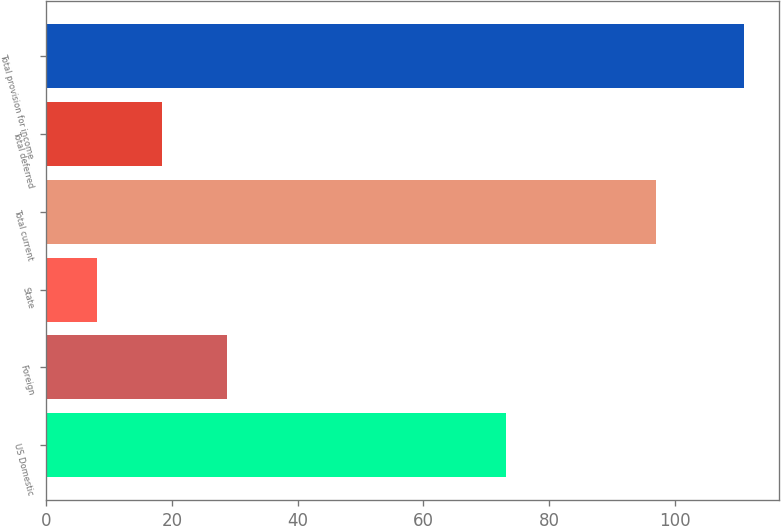Convert chart. <chart><loc_0><loc_0><loc_500><loc_500><bar_chart><fcel>US Domestic<fcel>Foreign<fcel>State<fcel>Total current<fcel>Total deferred<fcel>Total provision for income<nl><fcel>73.1<fcel>28.7<fcel>8.1<fcel>97<fcel>18.4<fcel>111.1<nl></chart> 